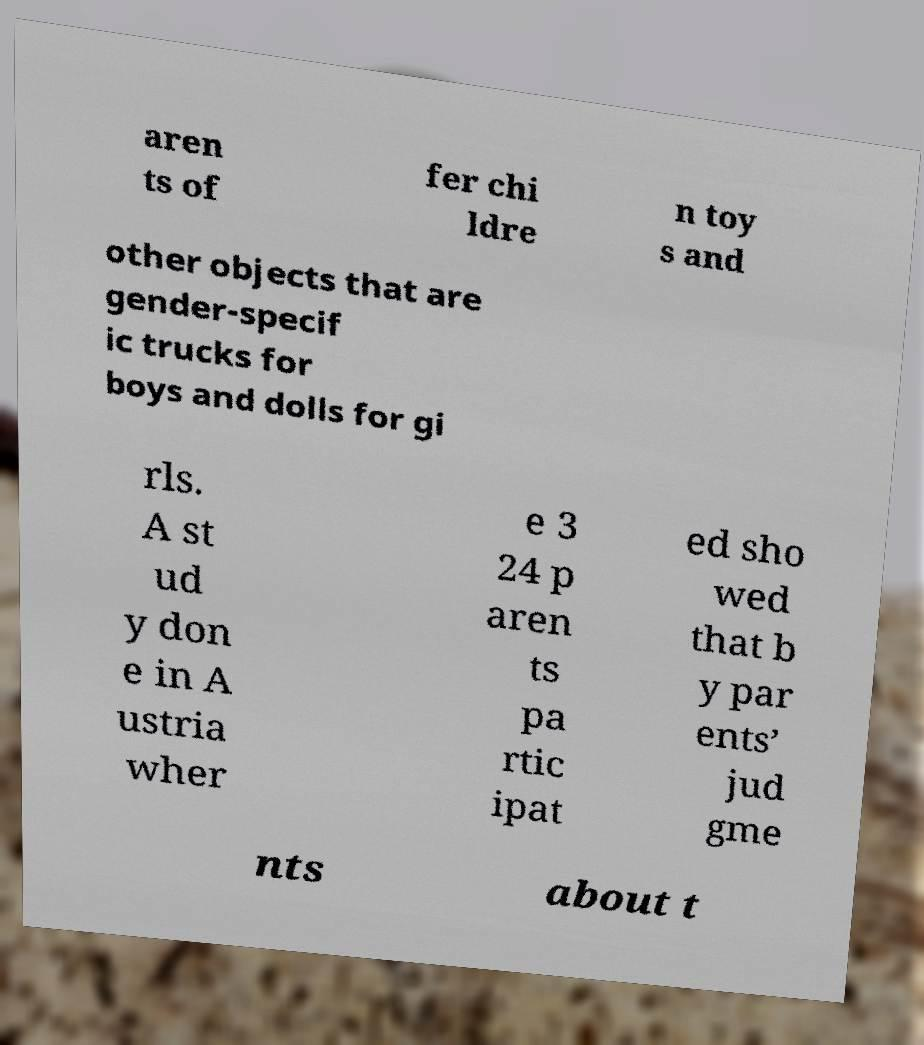Could you extract and type out the text from this image? aren ts of fer chi ldre n toy s and other objects that are gender-specif ic trucks for boys and dolls for gi rls. A st ud y don e in A ustria wher e 3 24 p aren ts pa rtic ipat ed sho wed that b y par ents’ jud gme nts about t 